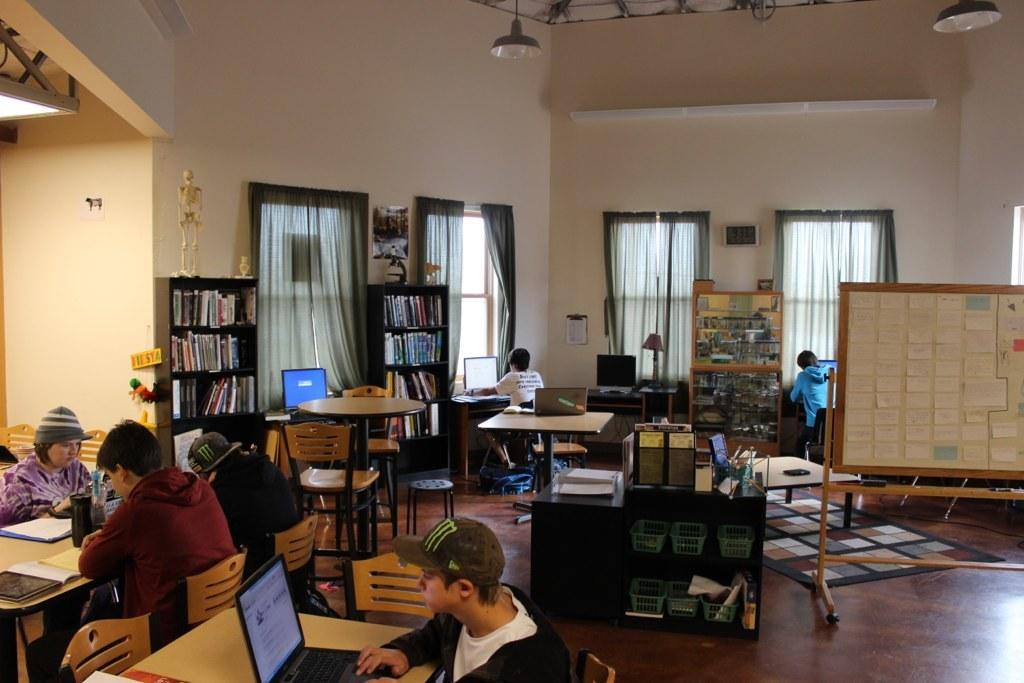What can be found on the bookshelf in the room? There is a bookshelf with books in the room. What is near the window in the room? There is a window with curtains in the room. What are the people in the room doing? The people are operating laptops on a table in the room. How are the people positioned while using the laptops? The people are sitting in chairs while using the laptops. What type of baseball equipment can be seen on the table in the image? There is no baseball equipment present in the image; the people are using laptops on the table. What color is the gold statue near the window in the image? There is no gold statue present in the image; there is only a window with curtains. 